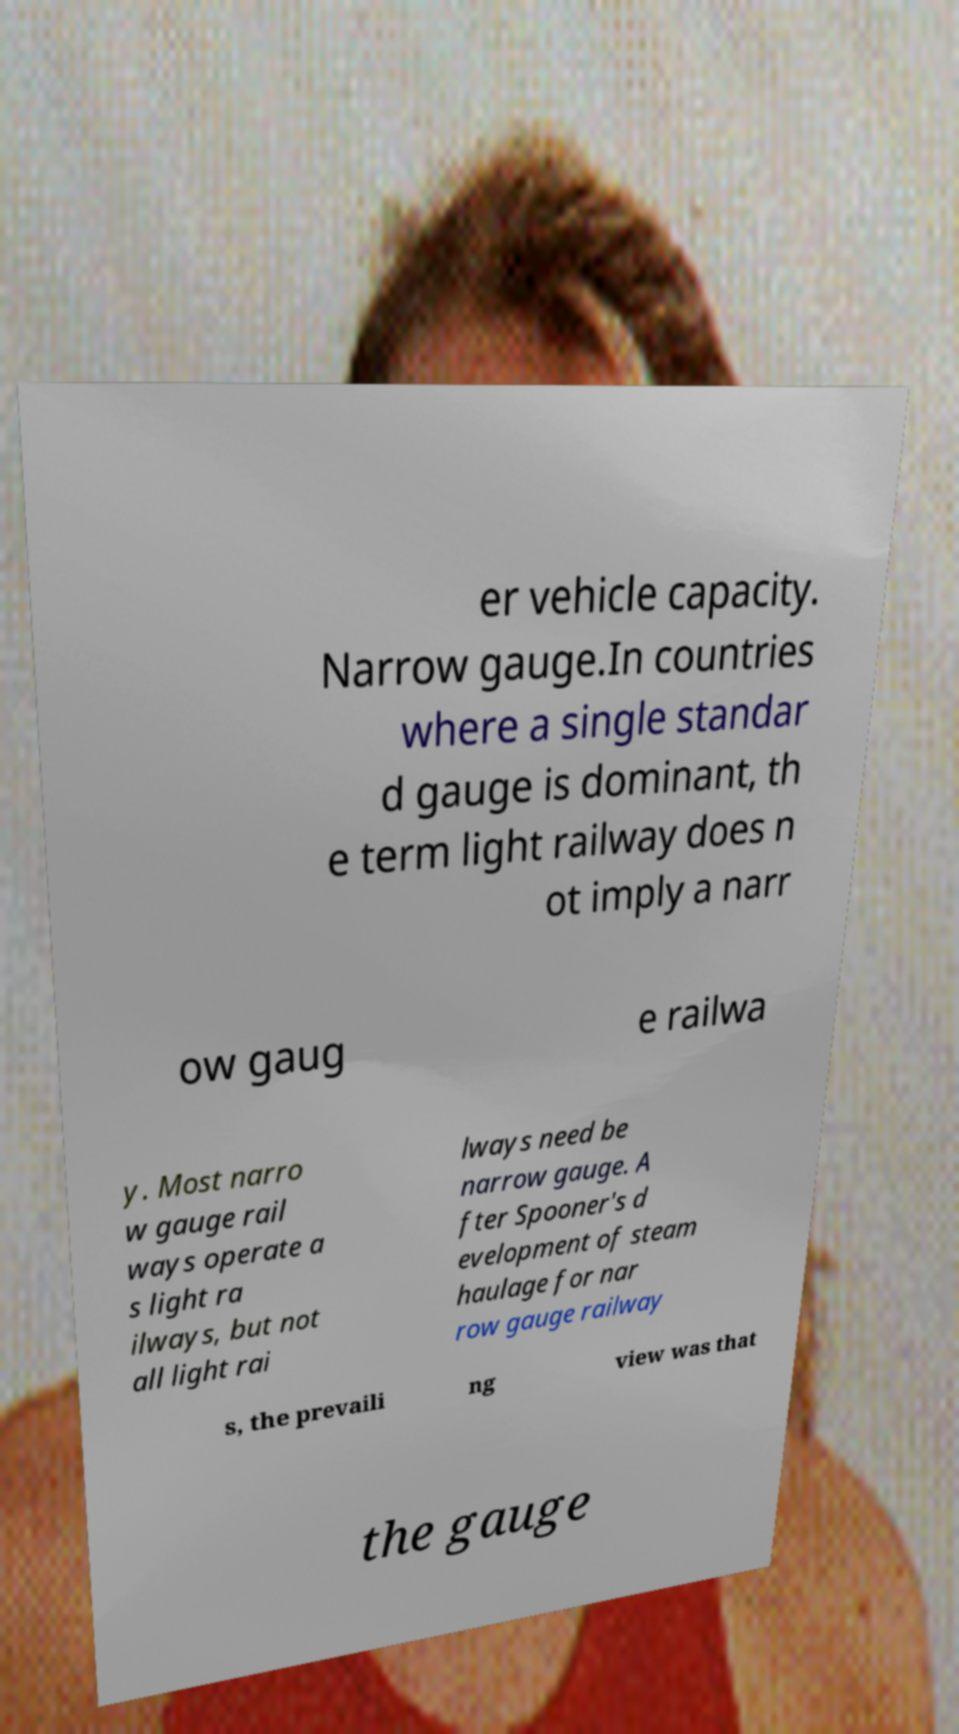Could you assist in decoding the text presented in this image and type it out clearly? er vehicle capacity. Narrow gauge.In countries where a single standar d gauge is dominant, th e term light railway does n ot imply a narr ow gaug e railwa y. Most narro w gauge rail ways operate a s light ra ilways, but not all light rai lways need be narrow gauge. A fter Spooner's d evelopment of steam haulage for nar row gauge railway s, the prevaili ng view was that the gauge 